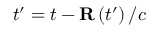Convert formula to latex. <formula><loc_0><loc_0><loc_500><loc_500>t ^ { \prime } = t - { R } \left ( t ^ { \prime } \right ) / c</formula> 